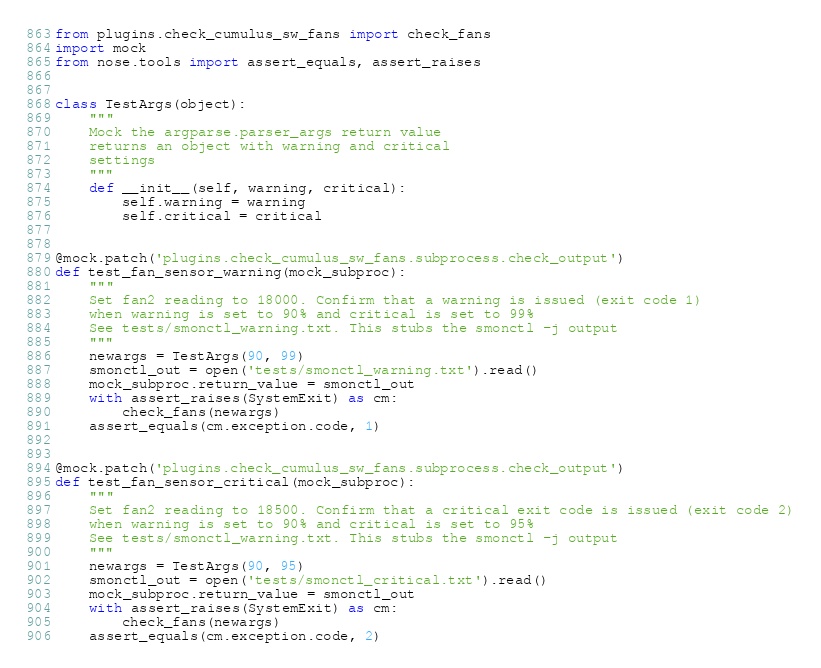<code> <loc_0><loc_0><loc_500><loc_500><_Python_>from plugins.check_cumulus_sw_fans import check_fans
import mock
from nose.tools import assert_equals, assert_raises


class TestArgs(object):
    """
    Mock the argparse.parser_args return value
    returns an object with warning and critical
    settings
    """
    def __init__(self, warning, critical):
        self.warning = warning
        self.critical = critical


@mock.patch('plugins.check_cumulus_sw_fans.subprocess.check_output')
def test_fan_sensor_warning(mock_subproc):
    """
    Set fan2 reading to 18000. Confirm that a warning is issued (exit code 1)
    when warning is set to 90% and critical is set to 99%
    See tests/smonctl_warning.txt. This stubs the smonctl -j output
    """
    newargs = TestArgs(90, 99)
    smonctl_out = open('tests/smonctl_warning.txt').read()
    mock_subproc.return_value = smonctl_out
    with assert_raises(SystemExit) as cm:
        check_fans(newargs)
    assert_equals(cm.exception.code, 1)


@mock.patch('plugins.check_cumulus_sw_fans.subprocess.check_output')
def test_fan_sensor_critical(mock_subproc):
    """
    Set fan2 reading to 18500. Confirm that a critical exit code is issued (exit code 2)
    when warning is set to 90% and critical is set to 95%
    See tests/smonctl_warning.txt. This stubs the smonctl -j output
    """
    newargs = TestArgs(90, 95)
    smonctl_out = open('tests/smonctl_critical.txt').read()
    mock_subproc.return_value = smonctl_out
    with assert_raises(SystemExit) as cm:
        check_fans(newargs)
    assert_equals(cm.exception.code, 2)
</code> 